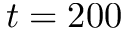<formula> <loc_0><loc_0><loc_500><loc_500>t = 2 0 0</formula> 